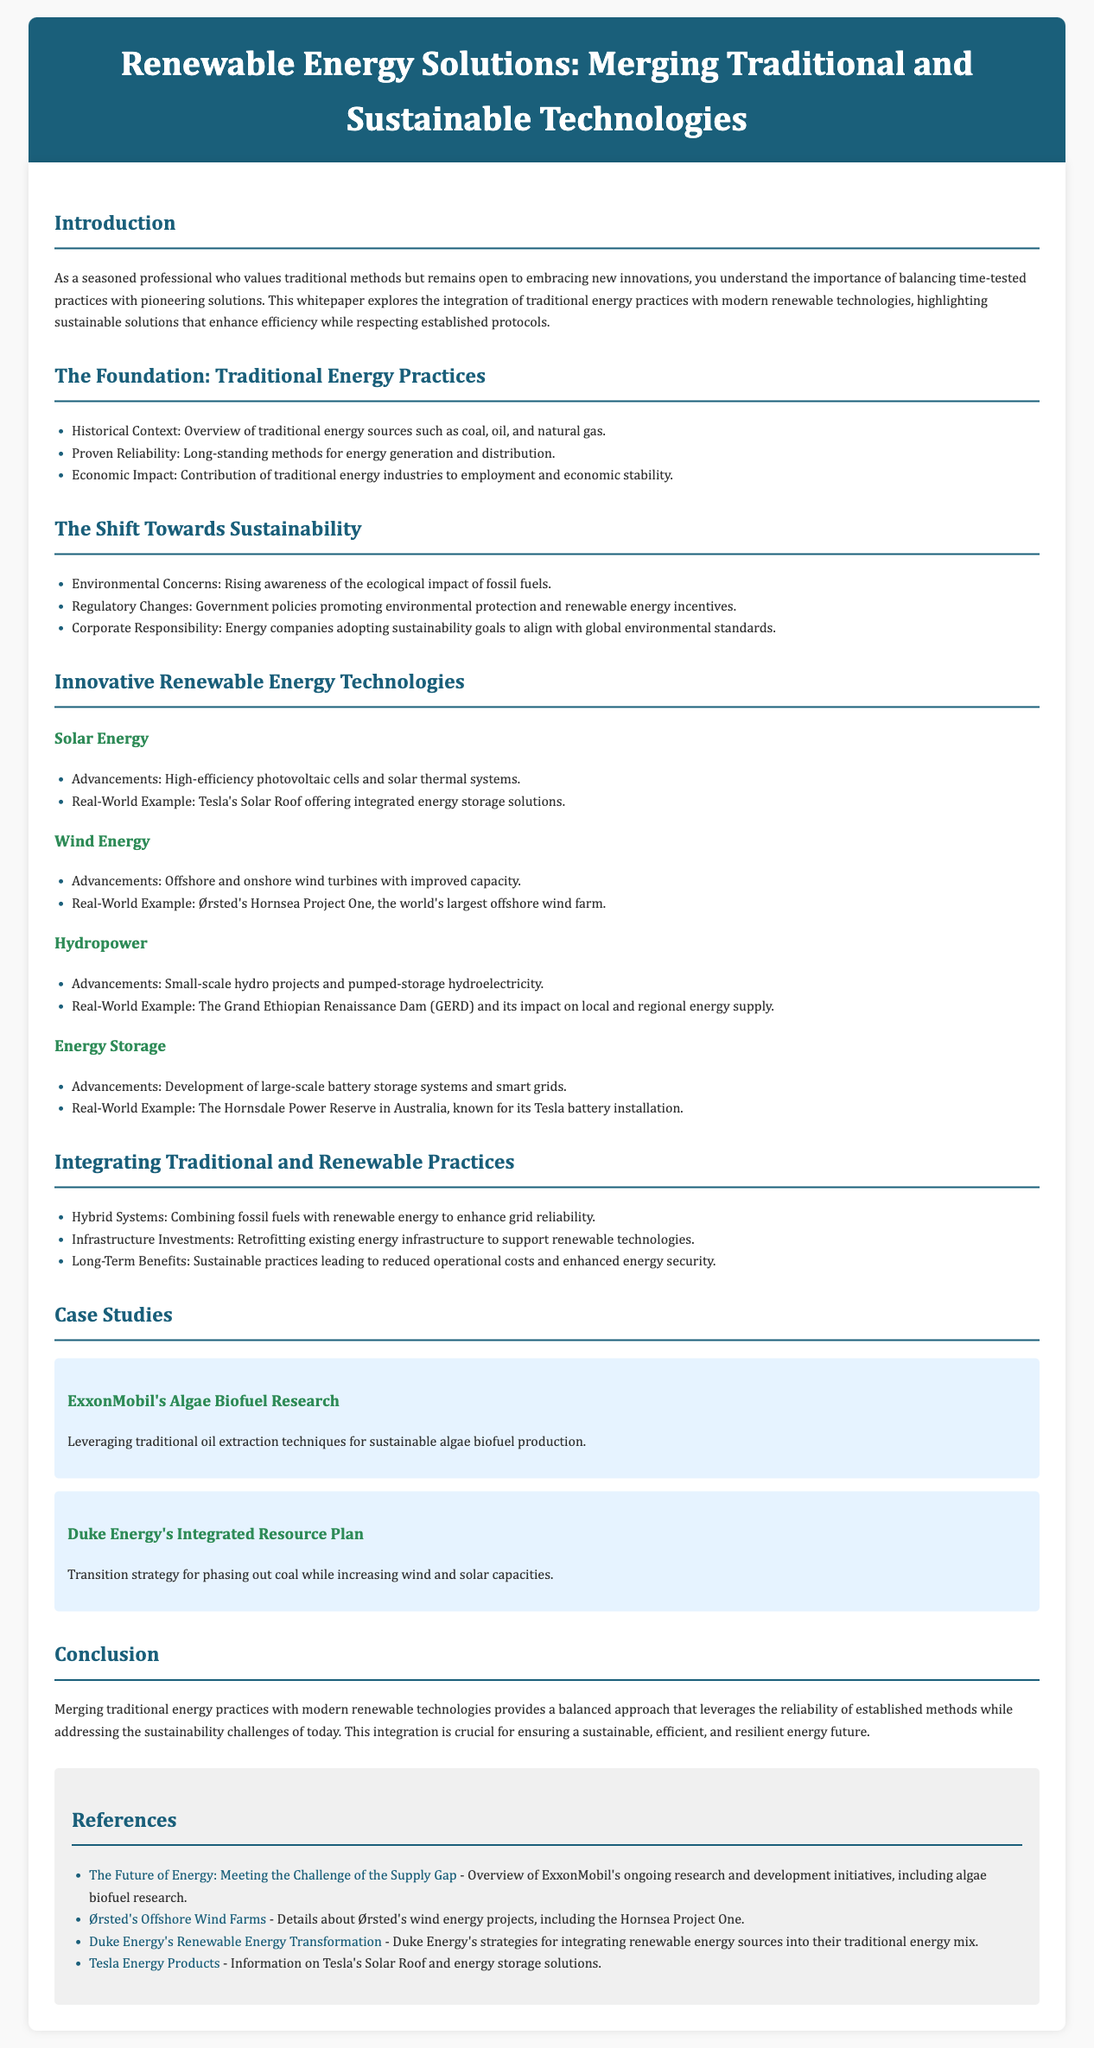What are traditional energy sources mentioned? The document lists coal, oil, and natural gas as traditional energy sources in the historical context section.
Answer: coal, oil, natural gas What is a real-world example of solar energy technology? The document provides Tesla's Solar Roof as a real-world example in the solar energy advancements section.
Answer: Tesla's Solar Roof What are the advancements in wind energy mentioned? The document states that offshore and onshore wind turbines have improved capacity as advancements in wind energy.
Answer: Offshore and onshore wind turbines with improved capacity Which company is associated with algae biofuel research? The case study section associates ExxonMobil with algae biofuel research.
Answer: ExxonMobil What is the main purpose of integrating traditional and renewable practices? The document highlights that it enhances grid reliability as the main purpose for integrating these practices.
Answer: Enhance grid reliability How does Duke Energy plan to transition away from coal? Duke Energy's strategy involves increasing wind and solar capacities according to the integrated resource plan section.
Answer: Increasing wind and solar capacities What long-term benefit is mentioned for sustainable practices? The document states that sustainable practices lead to reduced operational costs as a long-term benefit.
Answer: Reduced operational costs What type of document is this? The document is identified as a whitepaper focused on renewable energy solutions.
Answer: whitepaper What is highlighted in the conclusion about merging practices? The conclusion emphasizes that merging traditional practices with modern technologies is crucial for ensuring a sustainable energy future.
Answer: Crucial for ensuring a sustainable energy future 